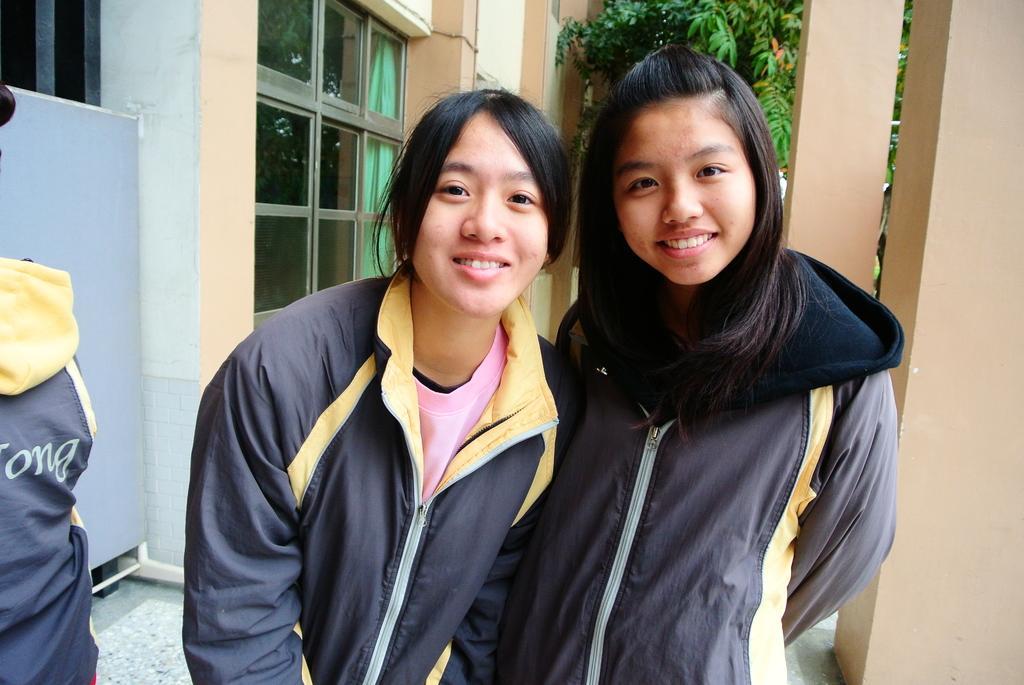Describe this image in one or two sentences. In this image we can see few people. There is a tree in the image. There is a curtain at the left side of the image. There is a window in the image. 